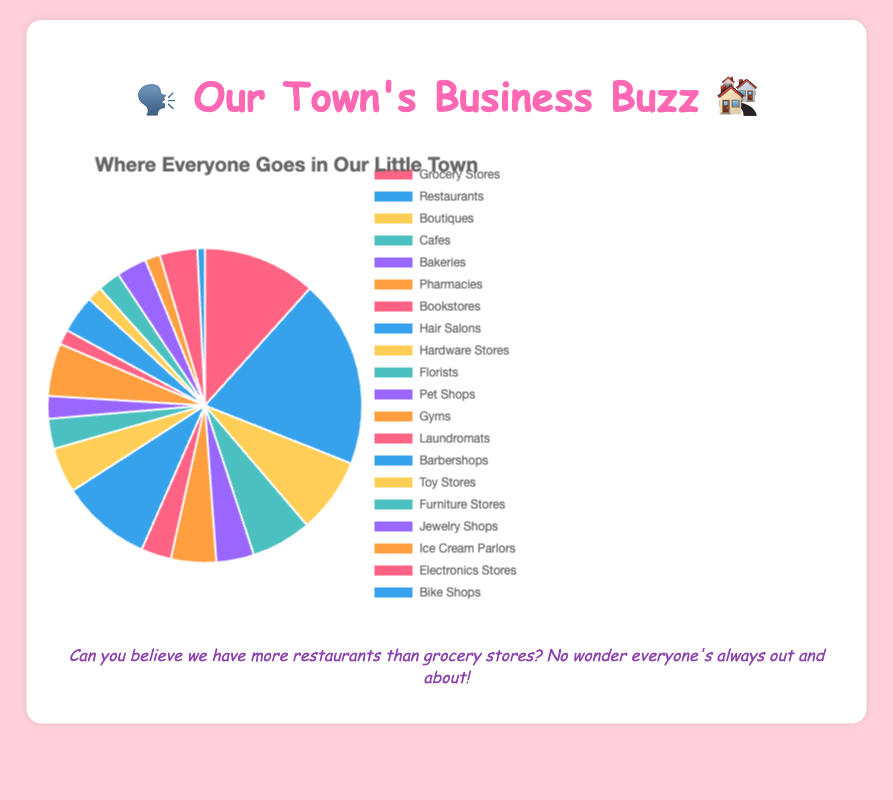Which type of local business is the most common in our town? By looking at the pie chart, the largest segment represents the most common business type. In this chart, the 'Restaurants' segment is the largest.
Answer: Restaurants How many more Restaurants are there compared to Hair Salons? First, find the 'Restaurants' segment which has 25 businesses, and the 'Hair Salons' segment which has 12. Subtract the Hair Salons from the Restaurants: 25 - 12 = 13
Answer: 13 What percentage of businesses are Bookstores and Florists combined? Add the counts of Bookstores (4) and Florists (4), getting a total of 8. There are 120 businesses in total. Calculate the percentage: (8/120) * 100 = 6.67%
Answer: 6.67% Are there more Cafes or Gyms in town? From the pie chart, Cafes have 8 and Gyms have 7. Since 8 is greater than 7, there are more Cafes.
Answer: Cafes Out of the total number of businesses, what fraction are Grocery Stores? There are 15 Grocery Stores out of a total of 120 businesses. The fraction is 15/120 which simplifies to 1/8.
Answer: 1/8 Which type of business is least common in our town? Looking at the smallest segment in the pie chart, the 'Bike Shops' segment is the smallest with 1 business.
Answer: Bike Shops How many total businesses are there related to food (Grocery Stores, Restaurants, Cafes, Bakeries, Ice Cream Parlors)? Add the counts: Grocery Stores (15) + Restaurants (25) + Cafes (8) + Bakeries (5) + Ice Cream Parlors (2) = 55
Answer: 55 Which has a larger share, Pharmacies or Hardware Stores, and by how much? Both Pharmacies and Hardware Stores have 6 businesses each, so their shares are the same.
Answer: Equal What is the total count for businesses related to personal care (Hair Salons and Barbershops)? Add the counts of Hair Salons (12) and Barbershops (5), getting 12 + 5 = 17.
Answer: 17 What is the most common non-food related business type? Ignoring all food-related businesses, the largest remaining segment is 'Hair Salons' with 12.
Answer: Hair Salons 